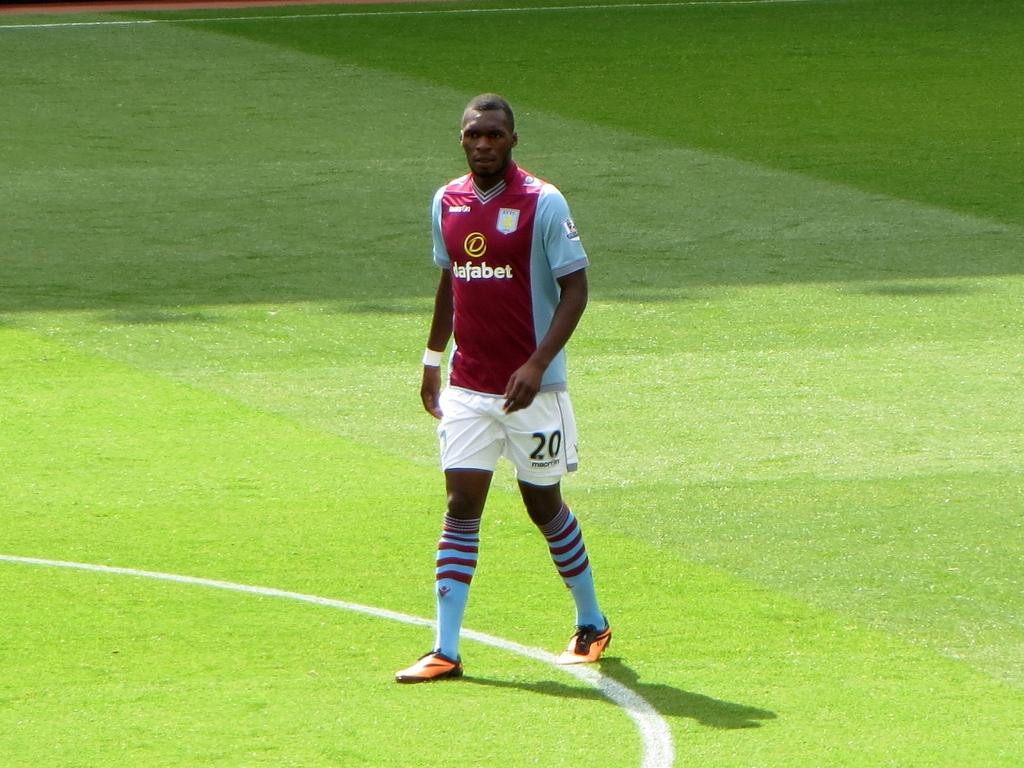<image>
Offer a succinct explanation of the picture presented. Soccer player wearing a jersey with the number 20 on it. 